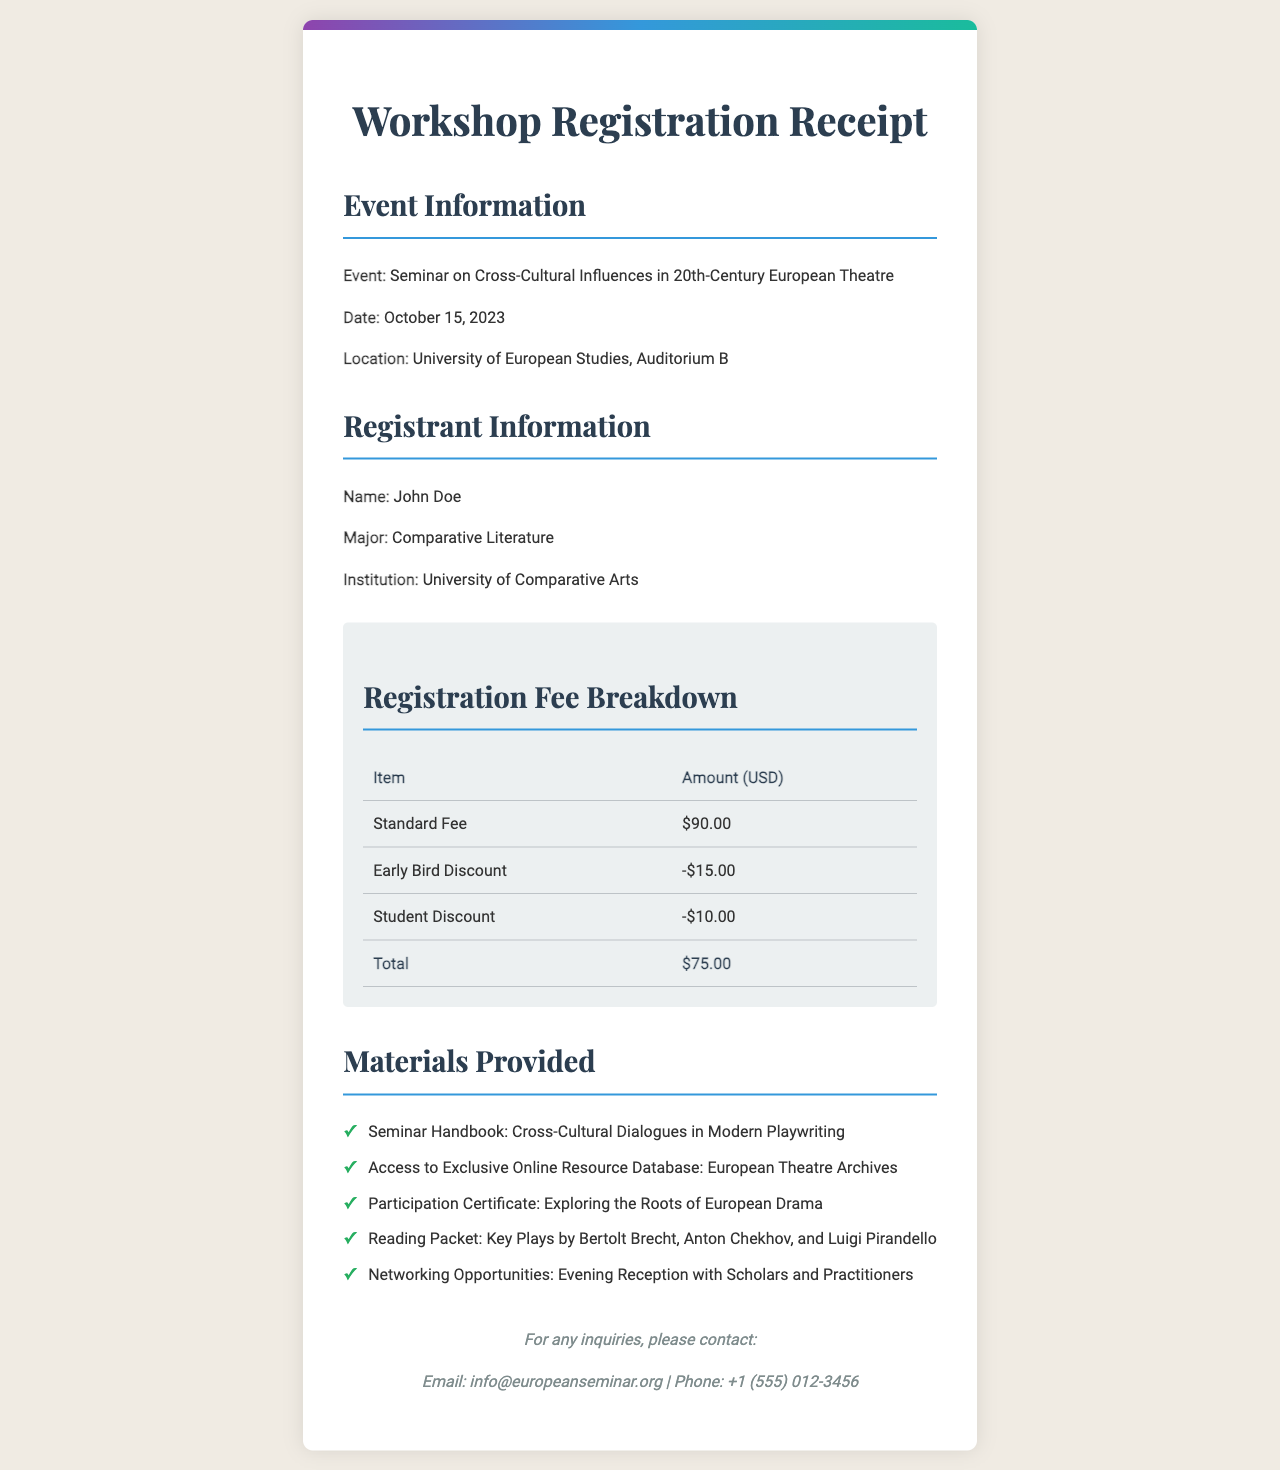What is the name of the seminar? The name of the seminar is explicitly mentioned as "Seminar on Cross-Cultural Influences in 20th-Century European Theatre."
Answer: Seminar on Cross-Cultural Influences in 20th-Century European Theatre What is the date of the seminar? The date of the seminar is clearly stated in the document as October 15, 2023.
Answer: October 15, 2023 How much is the standard registration fee? The standard registration fee is presented in the fee breakdown as $90.00.
Answer: $90.00 What is the total amount after deductions? The total amount after applying the discounts is noted in the fee breakdown as $75.00.
Answer: $75.00 What materials are provided? The materials provided are listed, including items such as "Seminar Handbook: Cross-Cultural Dialogues in Modern Playwriting."
Answer: Seminar Handbook: Cross-Cultural Dialogues in Modern Playwriting Who is the registrant? The registrant's name is provided in the document as John Doe.
Answer: John Doe What discounts are applied? The discounts applied are detailed in the fee breakdown as "Early Bird Discount" and "Student Discount."
Answer: Early Bird Discount and Student Discount Where is the seminar location? The seminar's location is specified in the document as University of European Studies, Auditorium B.
Answer: University of European Studies, Auditorium B 